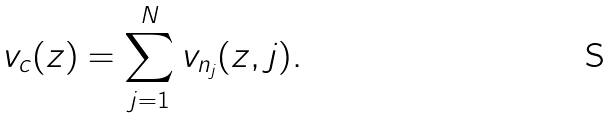Convert formula to latex. <formula><loc_0><loc_0><loc_500><loc_500>v _ { c } ( z ) = \sum _ { j = 1 } ^ { N } v _ { n _ { j } } ( z , j ) .</formula> 